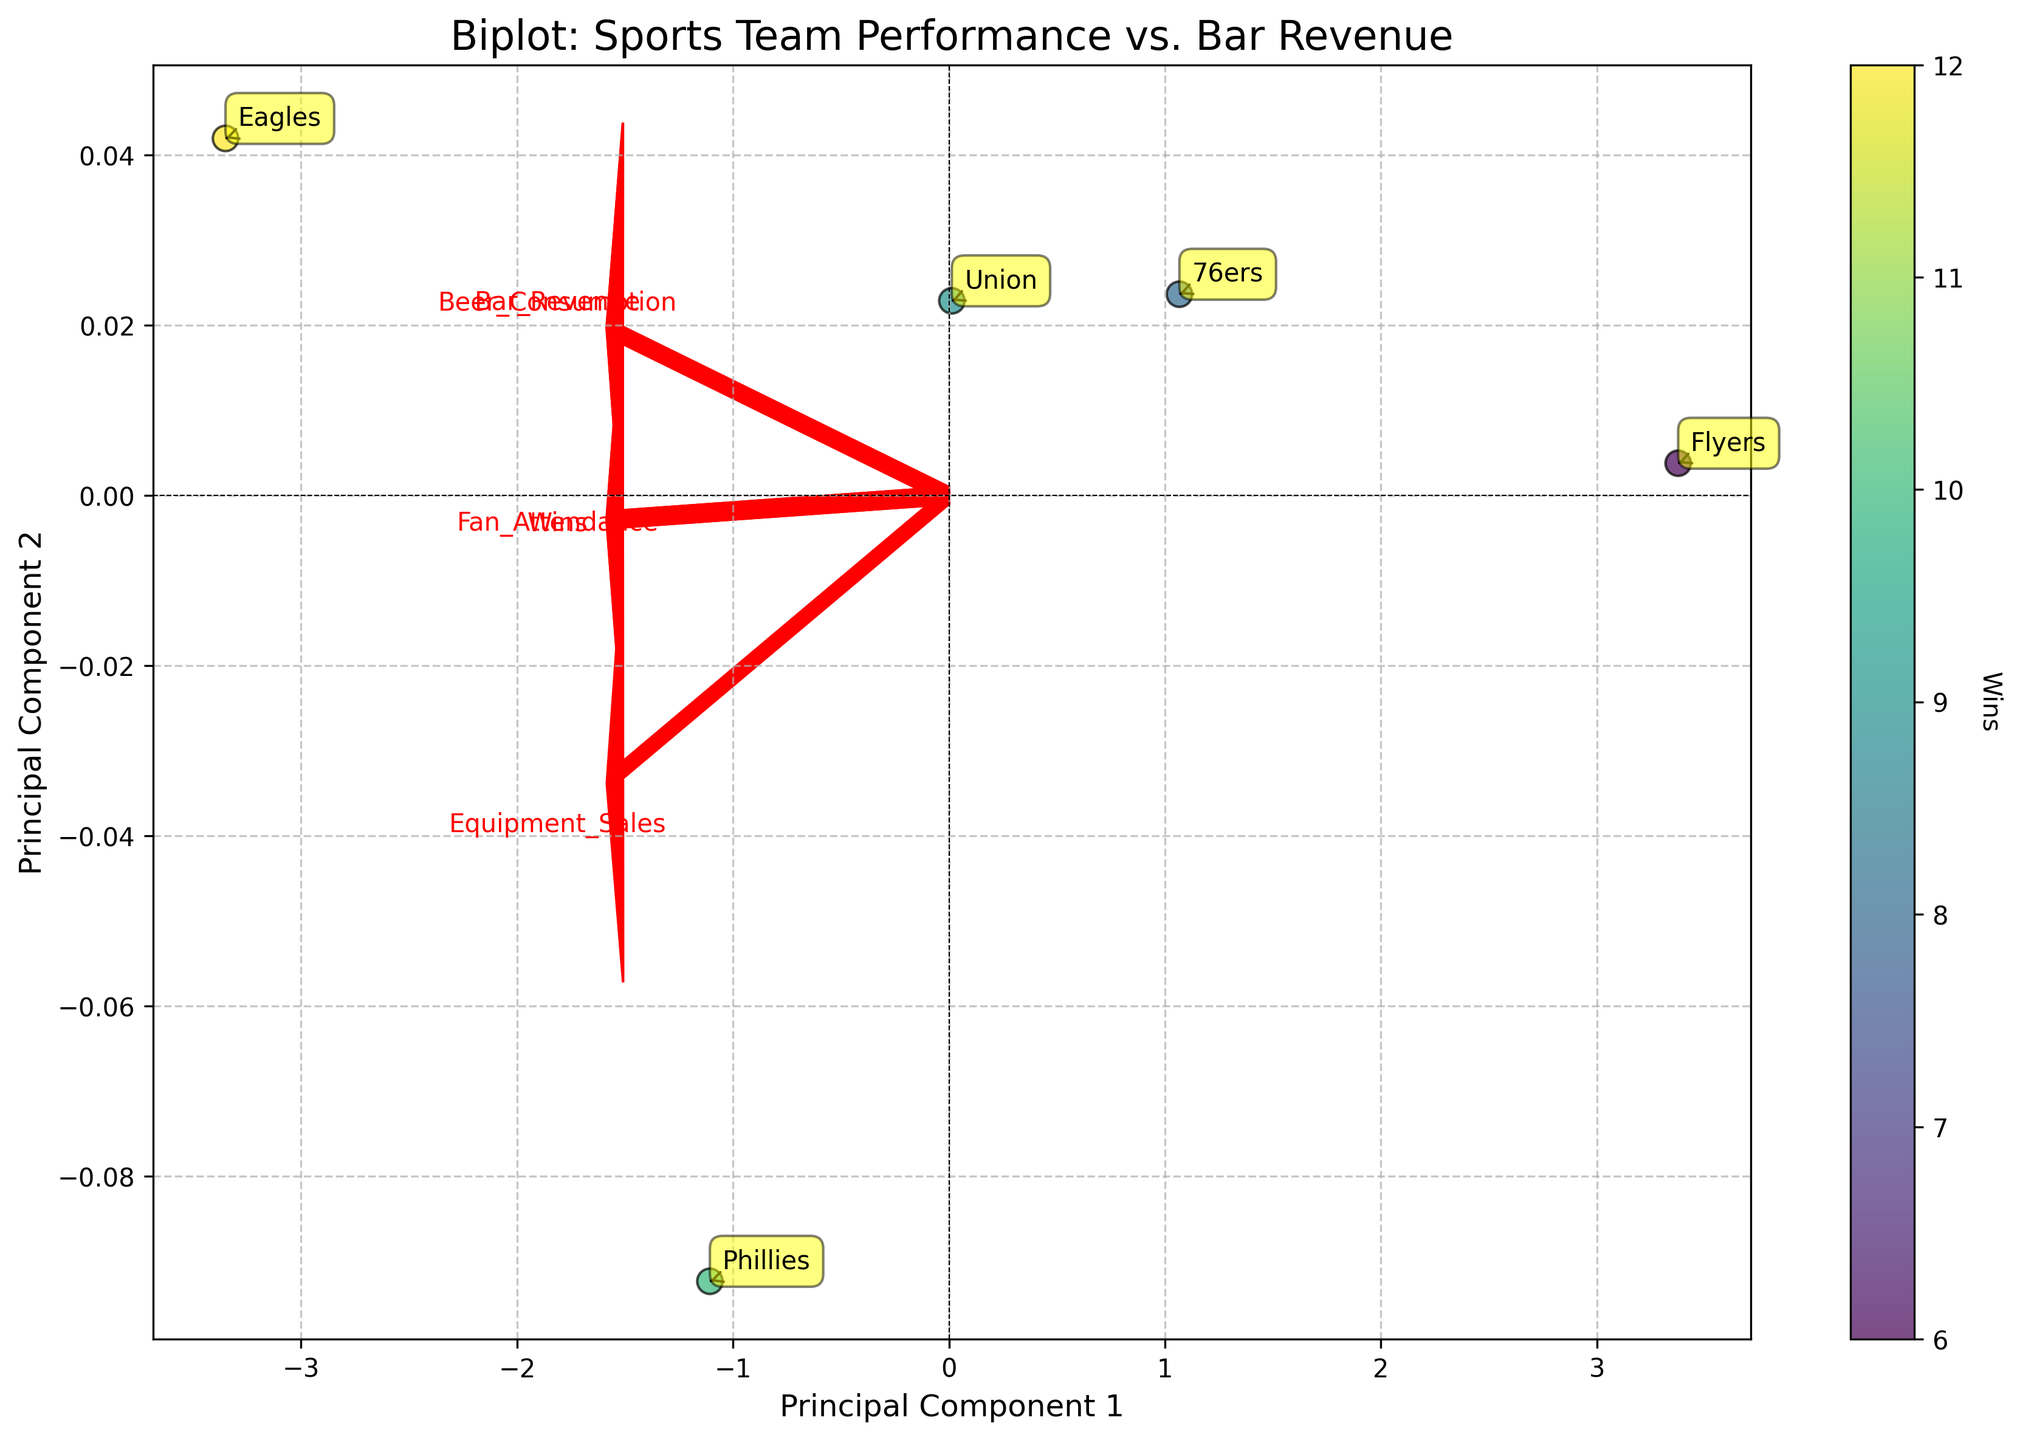What is the title of the plot? The title is usually located at the top of the plot, and it directly states the main focus of the visual representation. In this case, the title reads "Biplot: Sports Team Performance vs. Bar Revenue".
Answer: Biplot: Sports Team Performance vs. Bar Revenue How many data points (teams) are shown in the plot? By counting the annotations and the data points indicated in the scatter plot, we can see five teams displayed. These teams are the Eagles, 76ers, Phillies, Flyers, and Union.
Answer: 5 Which axis corresponds to Principal Component 1? The label for Principal Component 1 is on the horizontal axis, as the axis label 'Principal Component 1' is found at the bottom of the plot.
Answer: Horizontal Which team has the highest number of wins based on the color gradient? The color gradient indicates the number of wins, with darker colors representing more wins. From the plot, the team represented by the darkest color is the Eagles.
Answer: Eagles Do the vectors for Bar Revenue and Beer Consumption point in the same direction? By observing the arrows representing the feature vectors, we see that the vectors for Bar Revenue and Beer Consumption both point in roughly the same direction, indicating they are positively correlated.
Answer: Yes Which feature vector has the largest projection on Principal Component 1? To answer this, examine the length of the arrows along the Principal Component 1 axis. The arrow with the farthest extent along PC1 is representing Bar Revenue.
Answer: Bar Revenue Compare the position of the 76ers and Phillies; which team has a higher score on Principal Component 1? By looking at the projection along the x-axis (PC1) for each team, the Phillies have a higher score as their data point is further to the right compared to the 76ers.
Answer: Phillies What is the correlation between Wins and Fan Attendance based on the plot? Observing the arrow directions, the vectors for Wins and Fan Attendance roughly point in the same direction, showing they have a positive correlation.
Answer: Positive Which two features appear to be the least correlated? The vectors that point away from each other or are perpendicular indicate minimal or no correlation. Equipment Sales and Beer Consumption vectors appear to be pointing in almost opposite directions, suggesting they are the least correlated.
Answer: Equipment Sales and Beer Consumption What team is represented by the point located near the origin of the biplot? The data point closest to the origin, marked with an annotation, represents the Flyers team.
Answer: Flyers 